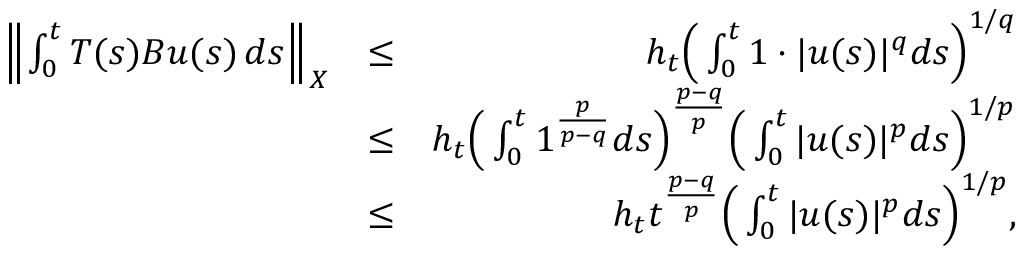Convert formula to latex. <formula><loc_0><loc_0><loc_500><loc_500>\begin{array} { r l r } { \left \| \int _ { 0 } ^ { t } T ( s ) B u ( s ) \, d s \right \| _ { X } } & { \leq } & { h _ { t } \left ( \int _ { 0 } ^ { t } 1 \cdot | u ( s ) | ^ { q } d s \right ) ^ { 1 / q } } \\ & { \leq } & { h _ { t } \left ( \int _ { 0 } ^ { t } 1 ^ { \frac { p } { p - q } } d s \right ) ^ { \frac { p - q } { p } } \left ( \int _ { 0 } ^ { t } | u ( s ) | ^ { p } d s \right ) ^ { 1 / p } } \\ & { \leq } & { h _ { t } t ^ { \frac { p - q } { p } } \left ( \int _ { 0 } ^ { t } | u ( s ) | ^ { p } d s \right ) ^ { 1 / p } , } \end{array}</formula> 